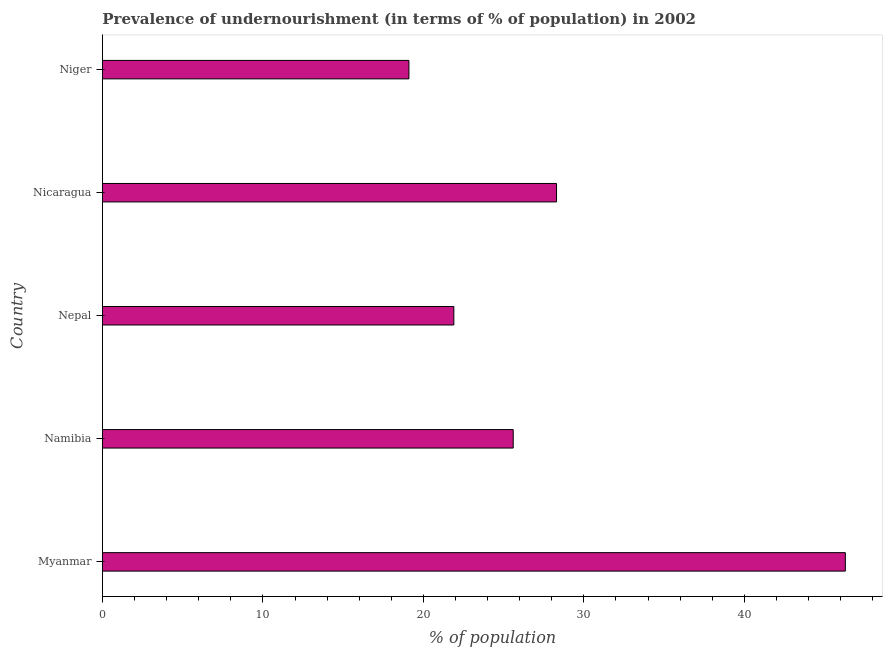What is the title of the graph?
Provide a succinct answer. Prevalence of undernourishment (in terms of % of population) in 2002. What is the label or title of the X-axis?
Provide a succinct answer. % of population. What is the percentage of undernourished population in Namibia?
Give a very brief answer. 25.6. Across all countries, what is the maximum percentage of undernourished population?
Provide a short and direct response. 46.3. Across all countries, what is the minimum percentage of undernourished population?
Give a very brief answer. 19.1. In which country was the percentage of undernourished population maximum?
Your response must be concise. Myanmar. In which country was the percentage of undernourished population minimum?
Offer a very short reply. Niger. What is the sum of the percentage of undernourished population?
Your answer should be very brief. 141.2. What is the difference between the percentage of undernourished population in Nicaragua and Niger?
Keep it short and to the point. 9.2. What is the average percentage of undernourished population per country?
Give a very brief answer. 28.24. What is the median percentage of undernourished population?
Provide a short and direct response. 25.6. In how many countries, is the percentage of undernourished population greater than 20 %?
Keep it short and to the point. 4. What is the ratio of the percentage of undernourished population in Namibia to that in Nicaragua?
Your answer should be very brief. 0.91. Is the difference between the percentage of undernourished population in Myanmar and Niger greater than the difference between any two countries?
Your answer should be compact. Yes. What is the difference between the highest and the lowest percentage of undernourished population?
Offer a terse response. 27.2. In how many countries, is the percentage of undernourished population greater than the average percentage of undernourished population taken over all countries?
Offer a very short reply. 2. Are the values on the major ticks of X-axis written in scientific E-notation?
Your response must be concise. No. What is the % of population in Myanmar?
Ensure brevity in your answer.  46.3. What is the % of population of Namibia?
Give a very brief answer. 25.6. What is the % of population in Nepal?
Provide a succinct answer. 21.9. What is the % of population of Nicaragua?
Make the answer very short. 28.3. What is the difference between the % of population in Myanmar and Namibia?
Provide a short and direct response. 20.7. What is the difference between the % of population in Myanmar and Nepal?
Provide a short and direct response. 24.4. What is the difference between the % of population in Myanmar and Niger?
Keep it short and to the point. 27.2. What is the difference between the % of population in Namibia and Nepal?
Give a very brief answer. 3.7. What is the difference between the % of population in Namibia and Nicaragua?
Your response must be concise. -2.7. What is the difference between the % of population in Nepal and Nicaragua?
Provide a succinct answer. -6.4. What is the difference between the % of population in Nepal and Niger?
Your answer should be compact. 2.8. What is the ratio of the % of population in Myanmar to that in Namibia?
Offer a very short reply. 1.81. What is the ratio of the % of population in Myanmar to that in Nepal?
Ensure brevity in your answer.  2.11. What is the ratio of the % of population in Myanmar to that in Nicaragua?
Your answer should be compact. 1.64. What is the ratio of the % of population in Myanmar to that in Niger?
Provide a succinct answer. 2.42. What is the ratio of the % of population in Namibia to that in Nepal?
Ensure brevity in your answer.  1.17. What is the ratio of the % of population in Namibia to that in Nicaragua?
Keep it short and to the point. 0.91. What is the ratio of the % of population in Namibia to that in Niger?
Keep it short and to the point. 1.34. What is the ratio of the % of population in Nepal to that in Nicaragua?
Keep it short and to the point. 0.77. What is the ratio of the % of population in Nepal to that in Niger?
Provide a succinct answer. 1.15. What is the ratio of the % of population in Nicaragua to that in Niger?
Make the answer very short. 1.48. 